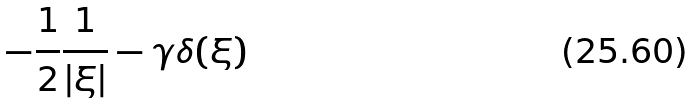Convert formula to latex. <formula><loc_0><loc_0><loc_500><loc_500>- \frac { 1 } { 2 } \frac { 1 } { | \xi | } - \gamma \delta ( \xi )</formula> 